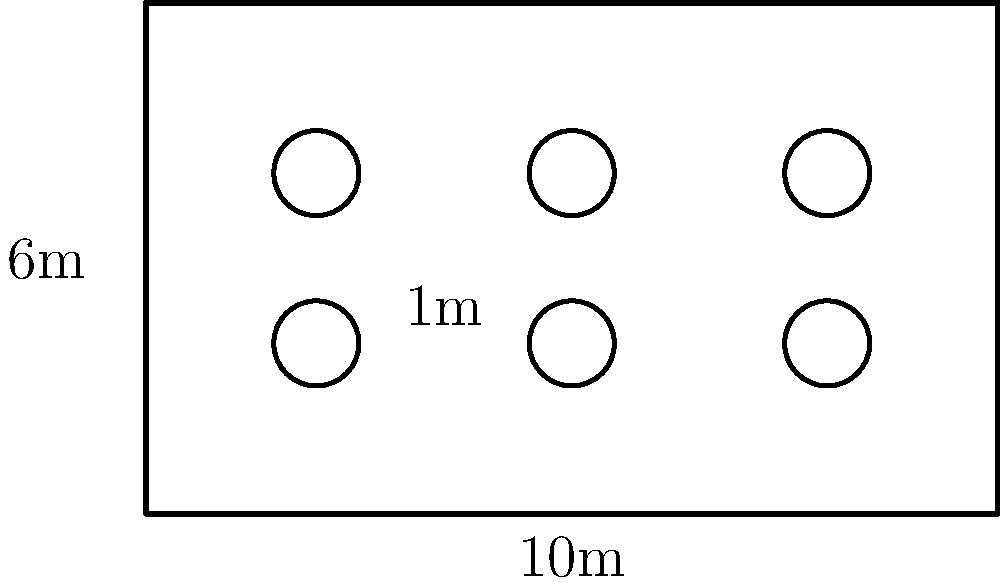For your dream wedding reception, you're planning to arrange circular tables in a rectangular hall. The hall measures 10m by 6m, and each table has a diameter of 1m. What is the maximum number of tables that can be arranged in the hall while maintaining a minimum distance of 1m between each table and from the walls? Let's approach this step-by-step:

1. First, we need to consider the effective space each table occupies:
   - Table diameter: 1m
   - Minimum spacing: 1m on each side
   - Total effective diameter: 1m + 1m + 1m = 3m

2. Now, let's calculate how many tables can fit along the length and width:
   - Length: 10m
   - Number of tables along length: $\lfloor \frac{10}{3} \rfloor = 3$ (we use the floor function as we can't have partial tables)
   - Width: 6m
   - Number of tables along width: $\lfloor \frac{6}{3} \rfloor = 2$

3. The total number of tables is the product of these two values:
   $3 \times 2 = 6$ tables

4. Let's verify if this arrangement fits:
   - Space occupied along length: $3 \times 3m = 9m$ (leaves 1m, which is acceptable)
   - Space occupied along width: $2 \times 3m = 6m$ (fits perfectly)

5. This arrangement satisfies all conditions:
   - Tables are 1m apart from each other
   - Tables are at least 1m from the walls
   - Maximum number of tables is achieved

Therefore, the maximum number of tables that can be arranged under these conditions is 6.
Answer: 6 tables 